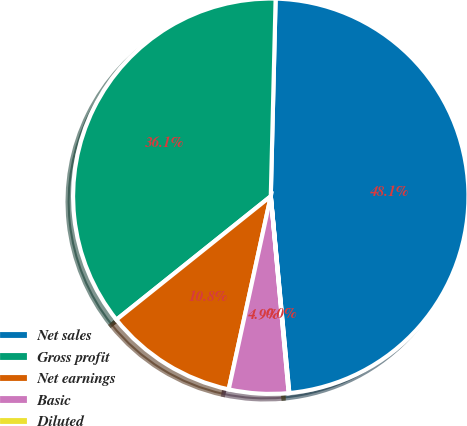Convert chart. <chart><loc_0><loc_0><loc_500><loc_500><pie_chart><fcel>Net sales<fcel>Gross profit<fcel>Net earnings<fcel>Basic<fcel>Diluted<nl><fcel>48.12%<fcel>36.13%<fcel>10.85%<fcel>4.86%<fcel>0.05%<nl></chart> 